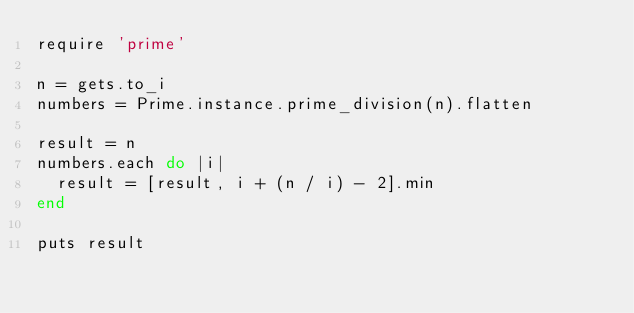<code> <loc_0><loc_0><loc_500><loc_500><_Ruby_>require 'prime'

n = gets.to_i
numbers = Prime.instance.prime_division(n).flatten

result = n
numbers.each do |i|
  result = [result, i + (n / i) - 2].min
end

puts result</code> 